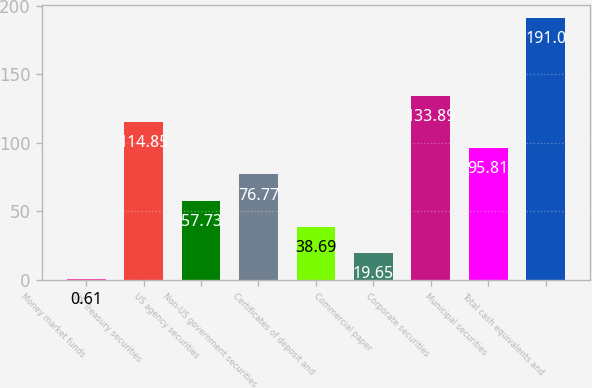Convert chart to OTSL. <chart><loc_0><loc_0><loc_500><loc_500><bar_chart><fcel>Money market funds<fcel>US Treasury securities<fcel>US agency securities<fcel>Non-US government securities<fcel>Certificates of deposit and<fcel>Commercial paper<fcel>Corporate securities<fcel>Municipal securities<fcel>Total cash equivalents and<nl><fcel>0.61<fcel>114.85<fcel>57.73<fcel>76.77<fcel>38.69<fcel>19.65<fcel>133.89<fcel>95.81<fcel>191<nl></chart> 